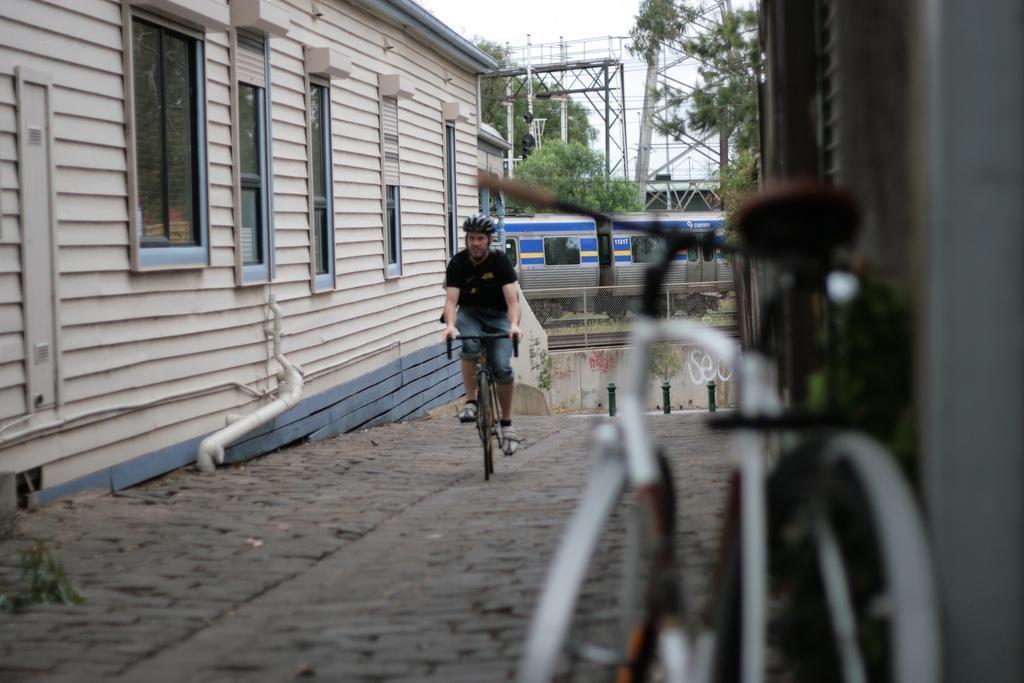How many people are wearing helmet?
Give a very brief answer. 1. 